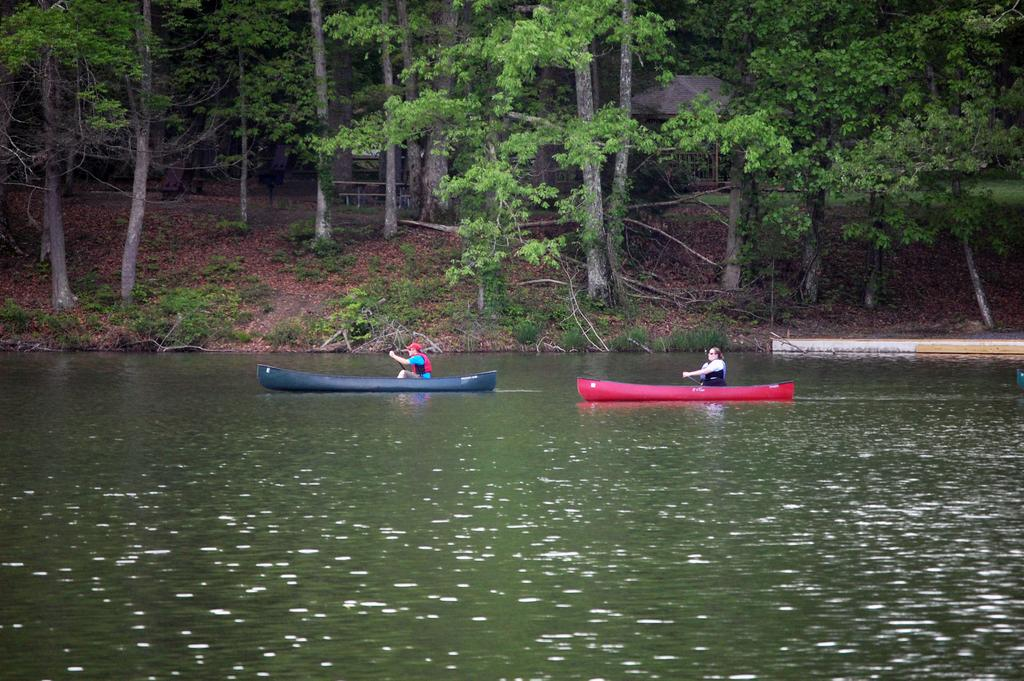What body of water is present at the bottom of the image? There is a river at the bottom of the image. What is happening in the river? There are boats in the river, and people are sitting in the boats. What can be seen in the background of the image? There are trees, a shed, and a fence in the background of the image. What is the name of the thing that was born in the image? There is no mention of a birth or a thing being born in the image. 